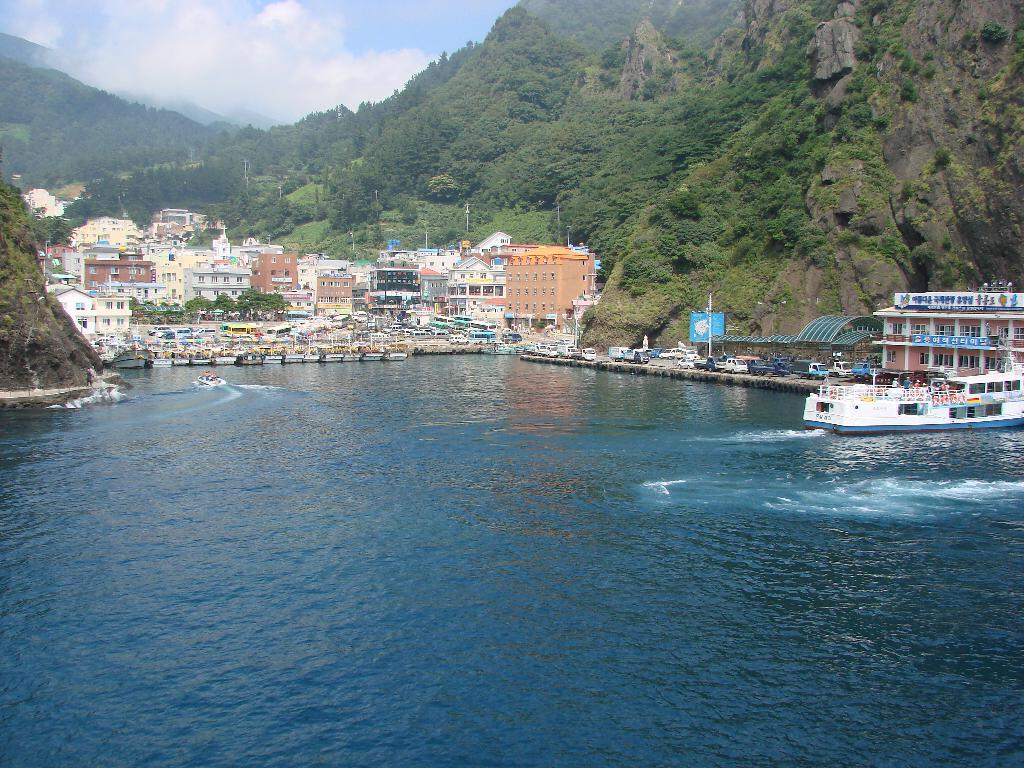What is on the water in the image? There are boats on the water in the image. What structures can be seen in the image? There are buildings visible in the image. What types of transportation are present on the ground in the image? Vehicles are present on the ground in the image. What type of vegetation is in the image? There are trees in the image. What geographical features can be seen in the image? Mountains are visible in the image. What is visible in the background of the image? The sky with clouds is present in the background of the image. Where is the jar of pickles located in the image? There is no jar of pickles present in the image. Can you tell me how many baseballs are visible in the image? There are no baseballs visible in the image. 